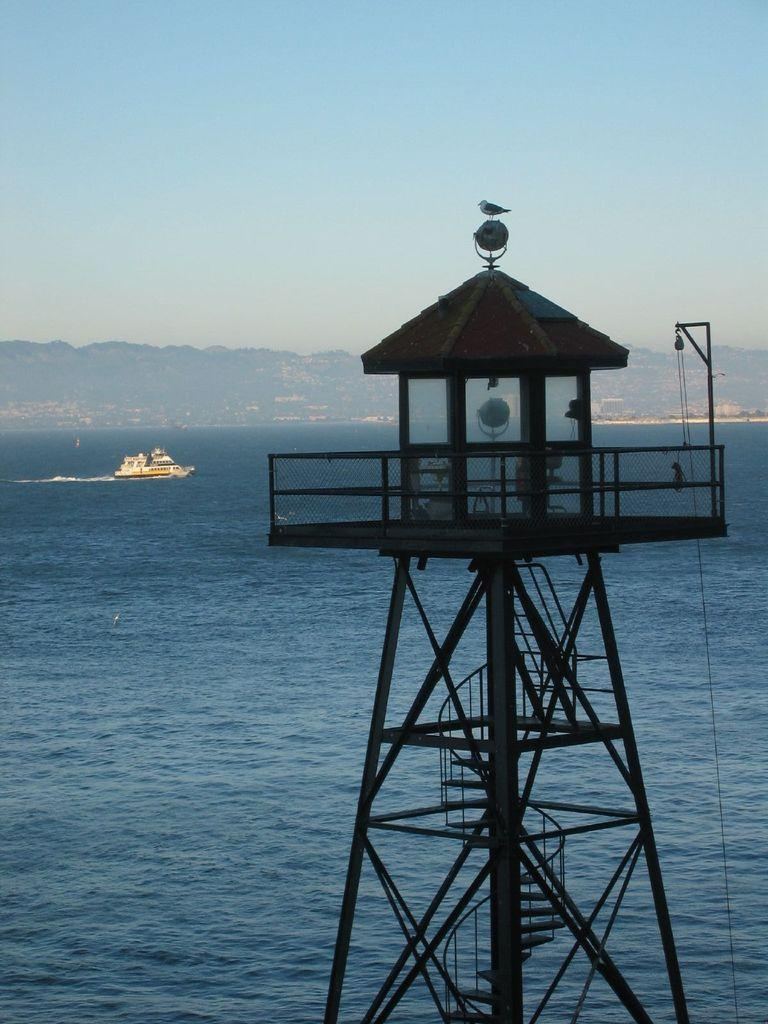What type of body of water is present in the image? There is an ocean in the image. What is happening on the ocean in the image? A ship is sailing on the ocean. What structure can be seen in the image? There is a tower in the image. Where is the tower located in the image? The tower is located at the front of the image. What can be seen at the end of the ocean in the image? There are hills visible at the end of the ocean. What type of question is being asked by the ship in the image? There is no indication in the image that the ship is asking a question. What is the tower made of in the image? The provided facts do not mention the material of the tower, so it cannot be determined from the image. 